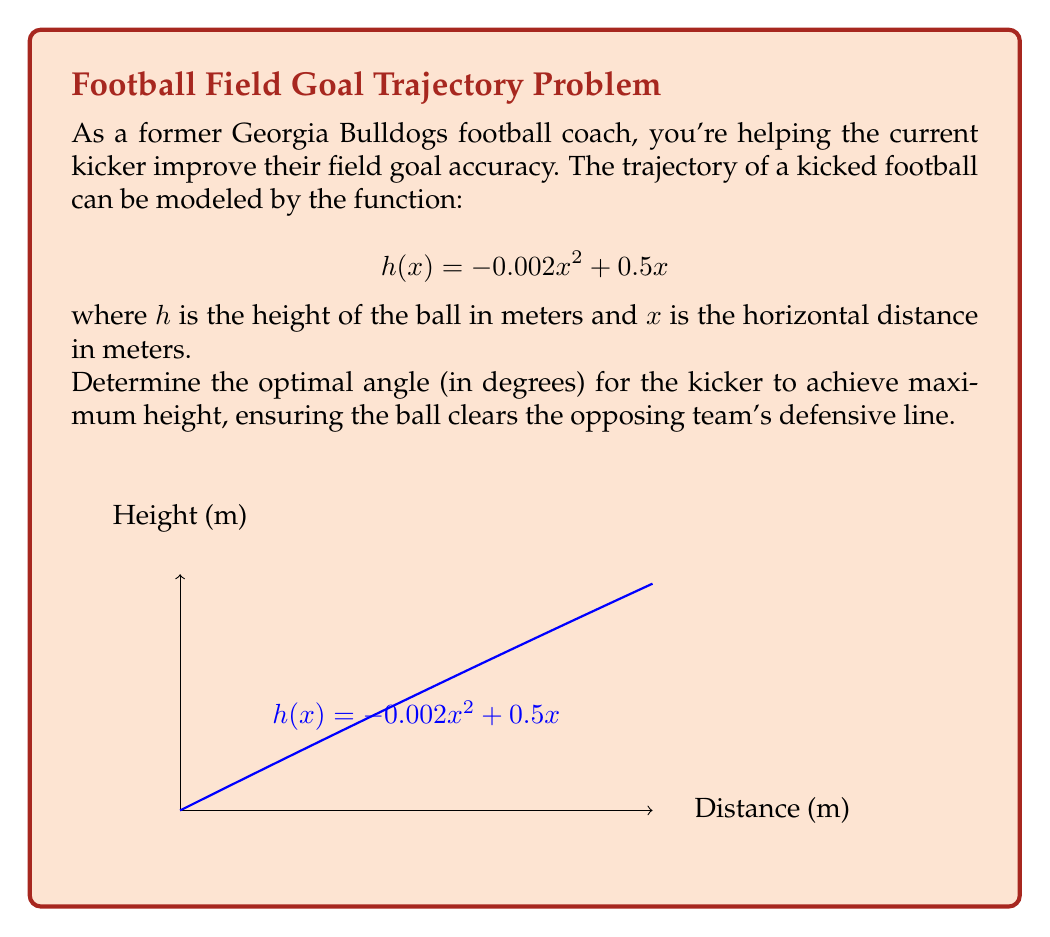Can you answer this question? To find the optimal angle, we need to determine where the ball reaches its maximum height. This occurs at the vertex of the parabola.

Step 1: Find the derivative of $h(x)$
$$h'(x) = -0.004x + 0.5$$

Step 2: Set $h'(x) = 0$ to find the critical point
$$-0.004x + 0.5 = 0$$
$$-0.004x = -0.5$$
$$x = 125$$

Step 3: The maximum height occurs at $x = 125$ meters. Calculate this height:
$$h(125) = -0.002(125)^2 + 0.5(125) = 31.25$$ meters

Step 4: To find the angle, we need to use the tangent function:
$$\tan(\theta) = \frac{\text{opposite}}{\text{adjacent}} = \frac{31.25}{125} = 0.25$$

Step 5: Take the inverse tangent (arctangent) to find the angle:
$$\theta = \tan^{-1}(0.25) \approx 14.04$$ degrees

Therefore, the optimal angle for the field goal kick is approximately 14.04 degrees.
Answer: $14.04^\circ$ 